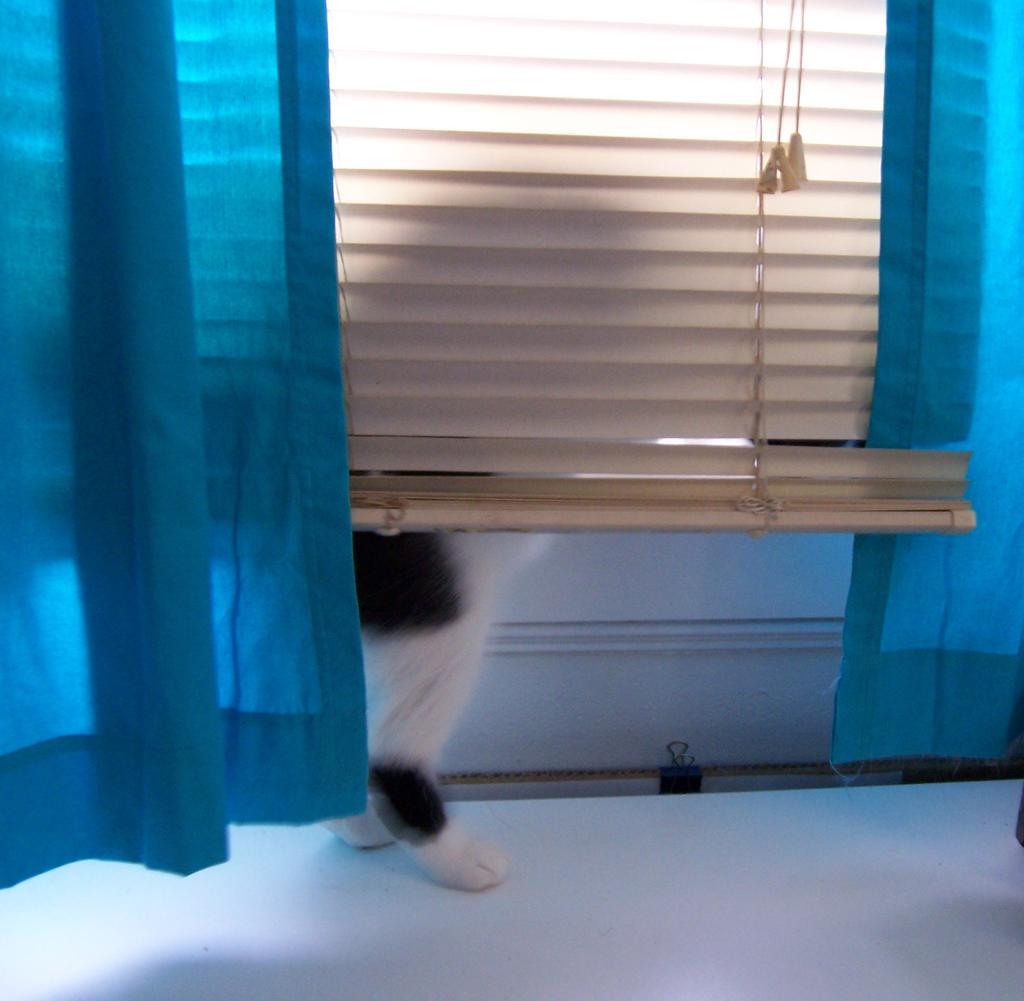Can you describe this image briefly? In this image we can see animal legs, curtains and wall. 